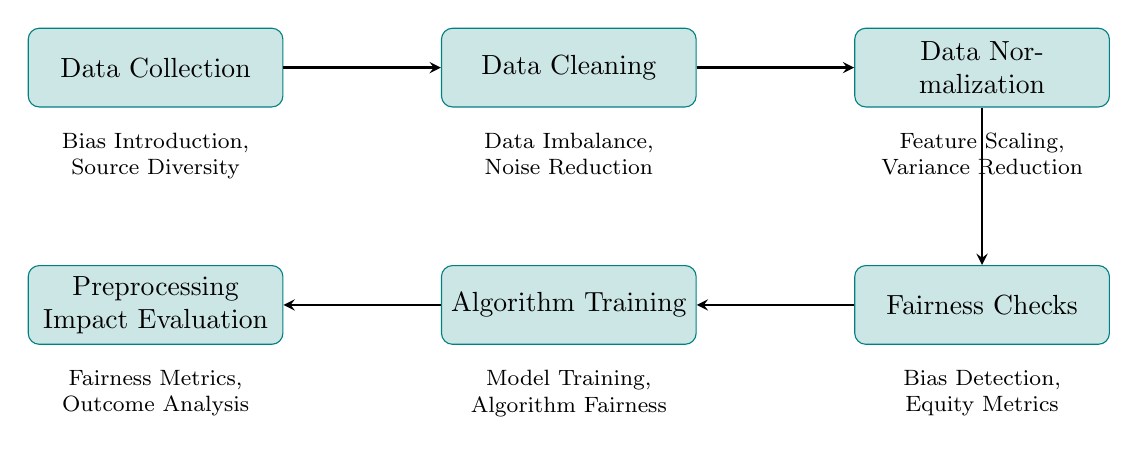What is the first step in the flow chart? The first step is labeled as "Data Collection," which represents the initial phase of gathering raw data from various sources.
Answer: Data Collection How many nodes are present in the diagram? By counting each stage presented in the diagram, we find that there are six distinct nodes describing the data processing stages.
Answer: Six What is the relationship between "Data Cleaning" and "Data Normalization"? The arrow directed from "Data Cleaning" to "Data Normalization" indicates that "Data Cleaning" directly precedes and leads into "Data Normalization," suggesting a flow of processes where cleaning data is necessary before normalizing it.
Answer: Directly precedes Which concept relates to "Fairness Checks"? The related concepts listed under "Fairness Checks" are "Bias Detection" and "Equity Metrics," indicating the focus of this stage on evaluating biases and ensuring equal treatment.
Answer: Bias Detection, Equity Metrics What is the last node in the flow chart? The last node shown in the diagram is "Preprocessing Impact Evaluation," which assesses how prior preprocessing steps affected the fairness of the algorithm outcomes.
Answer: Preprocessing Impact Evaluation Explain the relationship between "Algorithm Training" and "Fairness Checks." "Algorithm Training" occurs after "Fairness Checks," as indicated by the directed arrow. This means "Algorithm Training" uses the results from "Fairness Checks" to ensure that any detected biases are addressed before training the model with the data.
Answer: Occurs after What is one of the related concepts of "Data Normalization"? Under "Data Normalization," the related concepts are "Feature Scaling" and "Variance Reduction," both of which pertain to adjusting data values for fairness in model contribution.
Answer: Feature Scaling How does "Data Cleaning" influence data representation? "Data Cleaning," which involves tasks like removing inconsistencies and handling missing values, directly impacts data representation by minimizing data imbalance and reducing noise, ensuring a cleaner dataset for subsequent analysis.
Answer: Minimizing data imbalance, reducing noise 